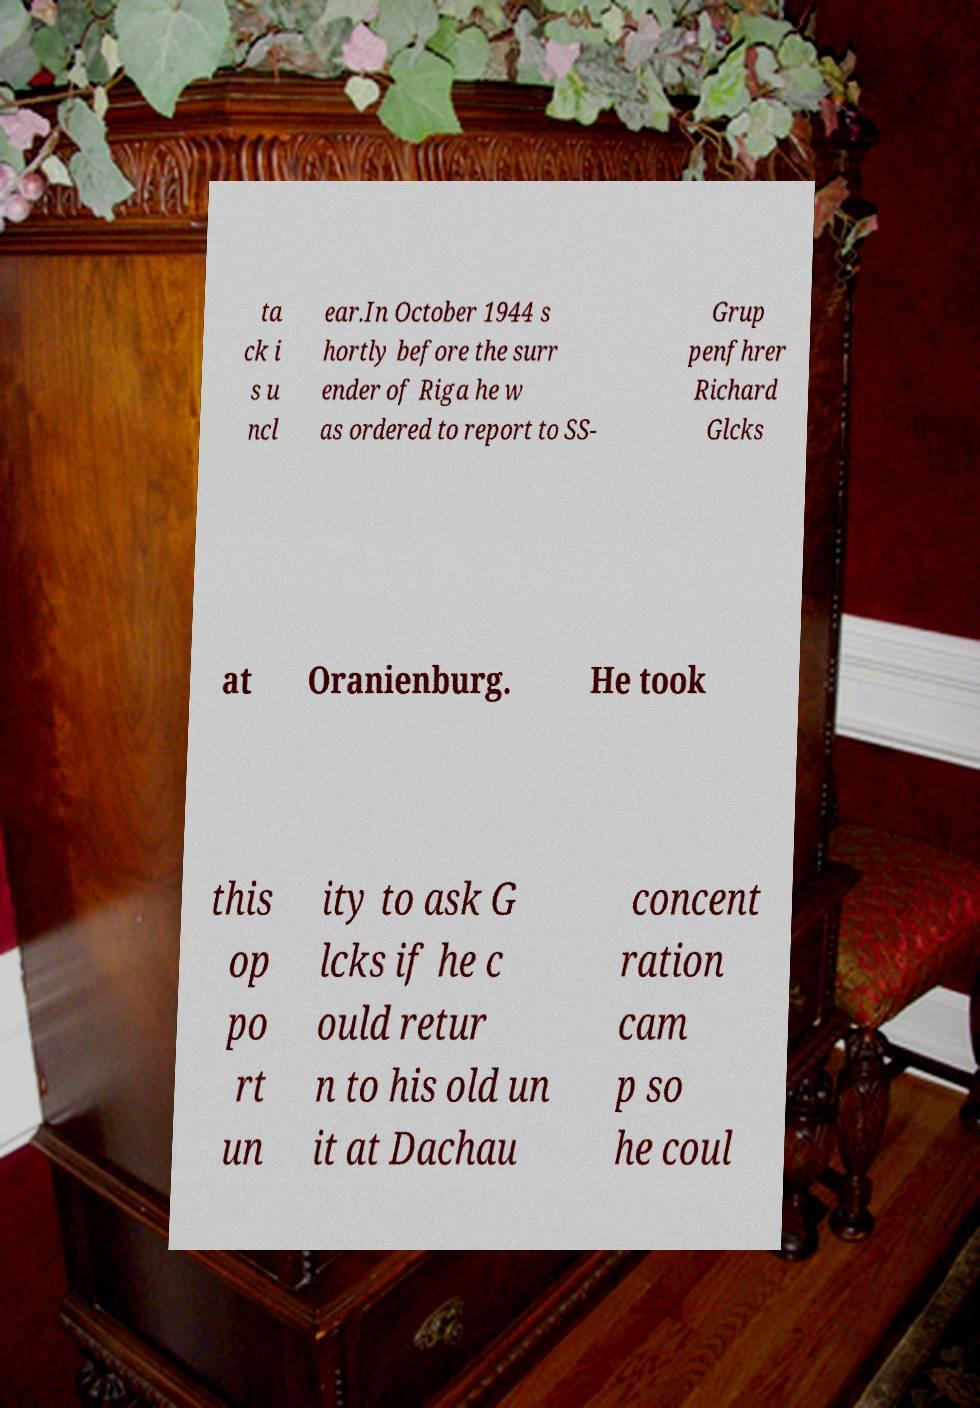Can you read and provide the text displayed in the image?This photo seems to have some interesting text. Can you extract and type it out for me? ta ck i s u ncl ear.In October 1944 s hortly before the surr ender of Riga he w as ordered to report to SS- Grup penfhrer Richard Glcks at Oranienburg. He took this op po rt un ity to ask G lcks if he c ould retur n to his old un it at Dachau concent ration cam p so he coul 